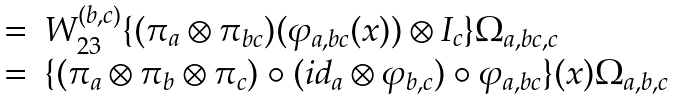<formula> <loc_0><loc_0><loc_500><loc_500>\begin{array} { r l } = & W ^ { ( b , c ) } _ { 2 3 } \{ ( \pi _ { a } \otimes \pi _ { b c } ) ( \varphi _ { a , b c } ( x ) ) \otimes I _ { c } \} \Omega _ { a , b c , c } \\ = & \{ ( \pi _ { a } \otimes \pi _ { b } \otimes \pi _ { c } ) \circ ( i d _ { a } \otimes \varphi _ { b , c } ) \circ \varphi _ { a , b c } \} ( x ) \Omega _ { a , b , c } \end{array}</formula> 